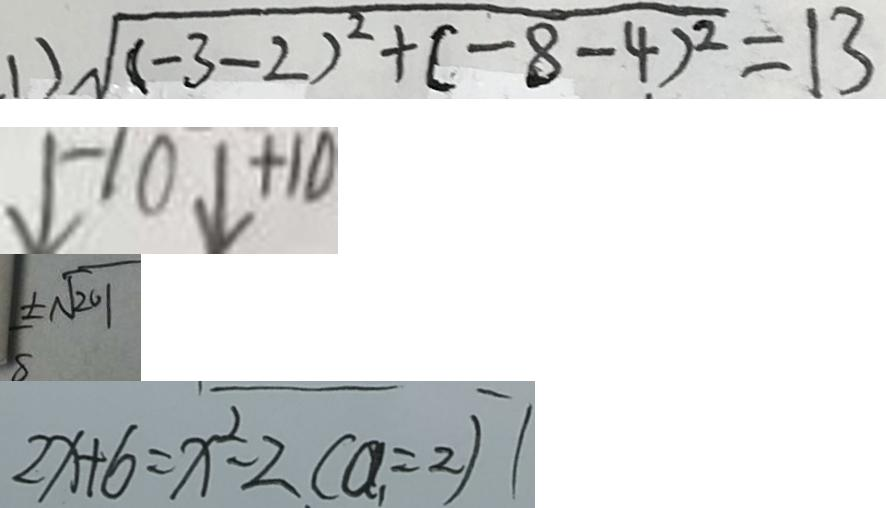<formula> <loc_0><loc_0><loc_500><loc_500>. 1 ) \sqrt { ( - 3 - 2 ) ^ { 2 } + ( - 8 - 4 ) ^ { 2 } } = 1 3 
 \downarrow - 1 0 \downarrow + 1 0 
 \pm \sqrt { 2 0 1 } 
 2 x + 6 = x ^ { 2 } - 2 ( a _ { 1 } = 2 ) 1</formula> 